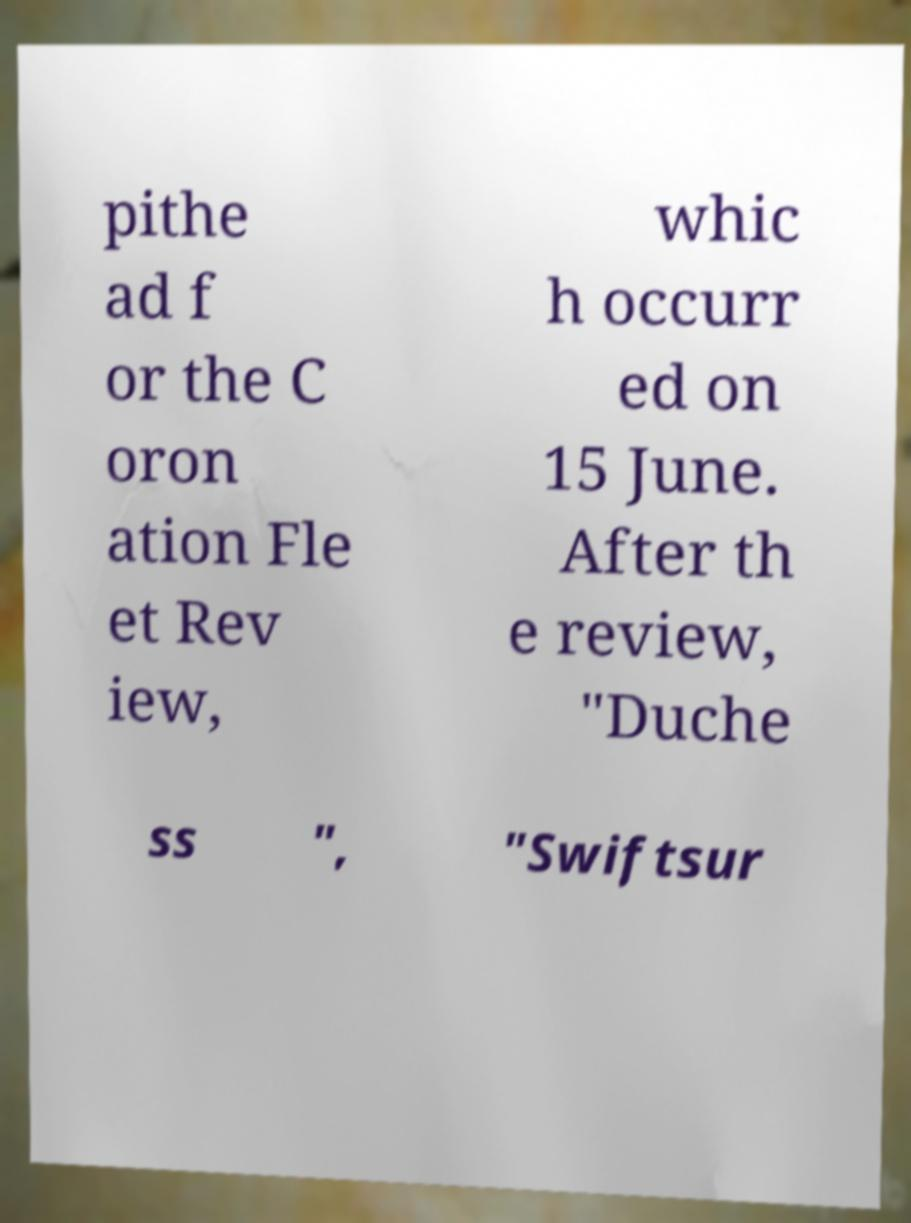Could you assist in decoding the text presented in this image and type it out clearly? pithe ad f or the C oron ation Fle et Rev iew, whic h occurr ed on 15 June. After th e review, "Duche ss ", "Swiftsur 